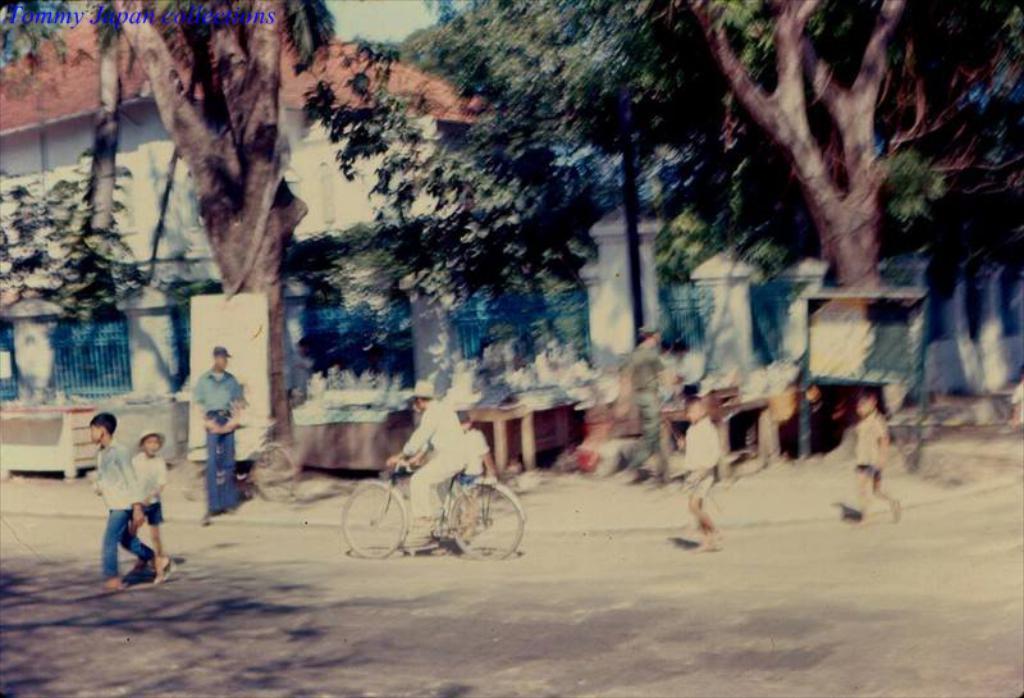How would you summarize this image in a sentence or two? In this image we can see some persons standing on the road and a person sitting on the bicycle. In the background we can see buildings, trees, pillars, grill and road. 